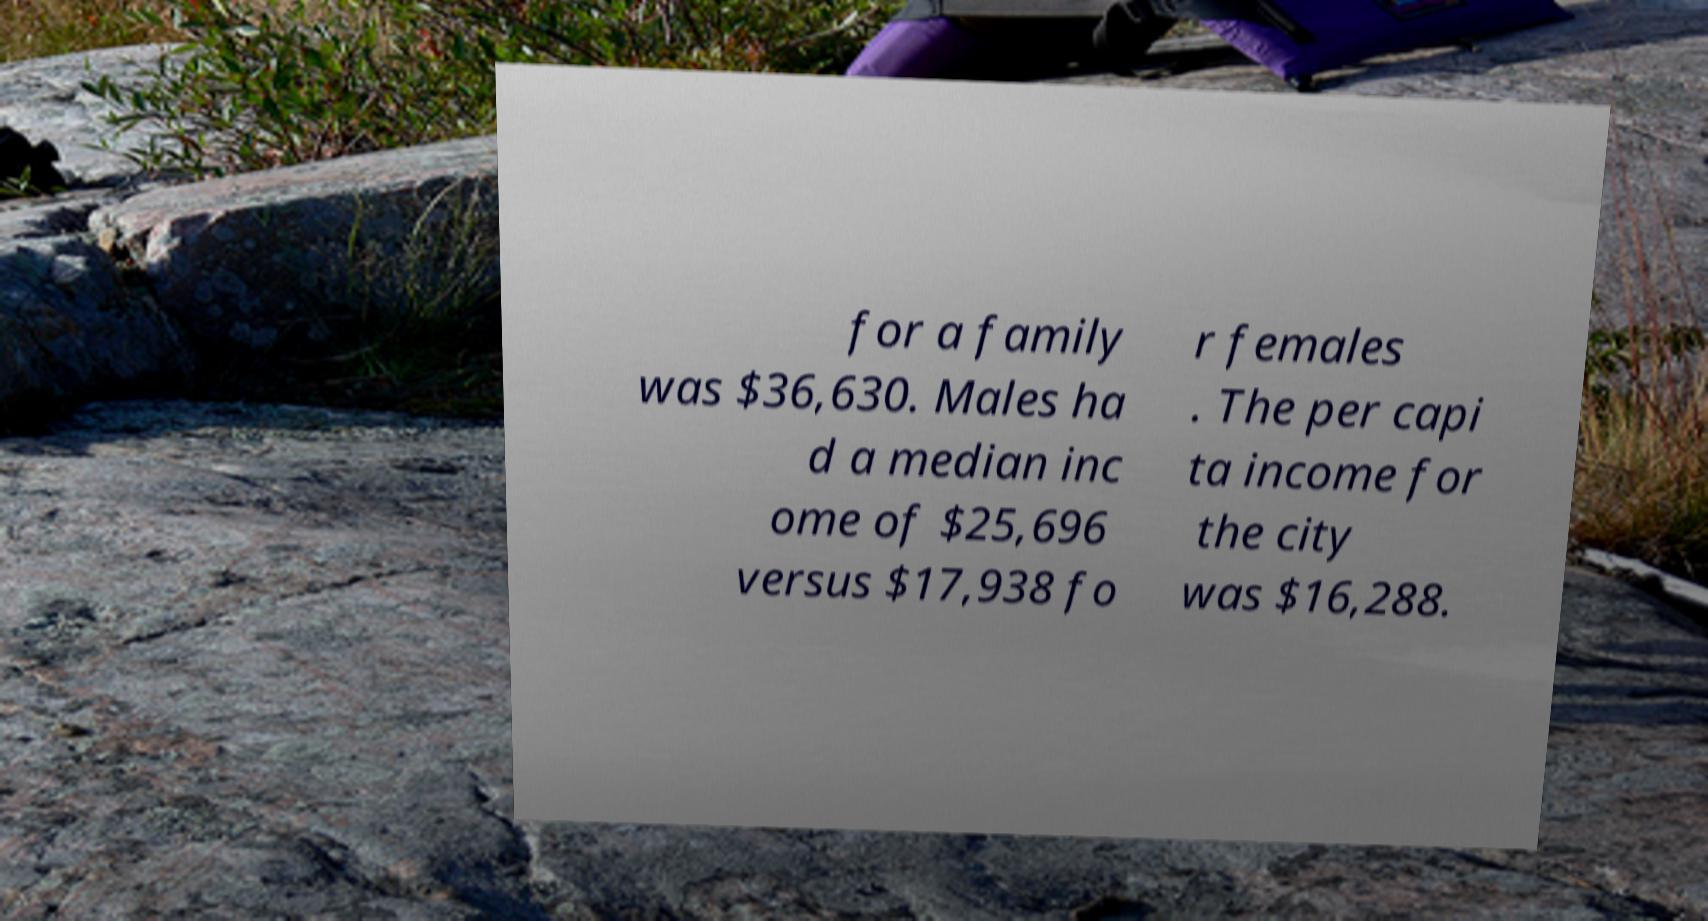Please read and relay the text visible in this image. What does it say? for a family was $36,630. Males ha d a median inc ome of $25,696 versus $17,938 fo r females . The per capi ta income for the city was $16,288. 